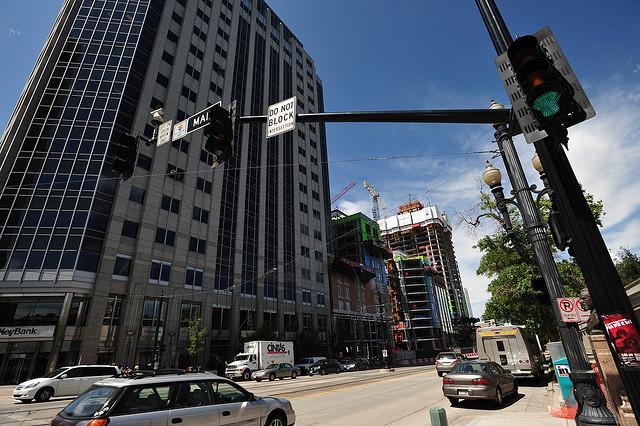What color is the station wagon?
Short answer required. Silver. What do the hand sign and the red light in the picture have in common?
Write a very short answer. Same color. Where was this pic taken?
Write a very short answer. City. Is the light green?
Answer briefly. Yes. Is the pic taken during the day?
Short answer required. Yes. 